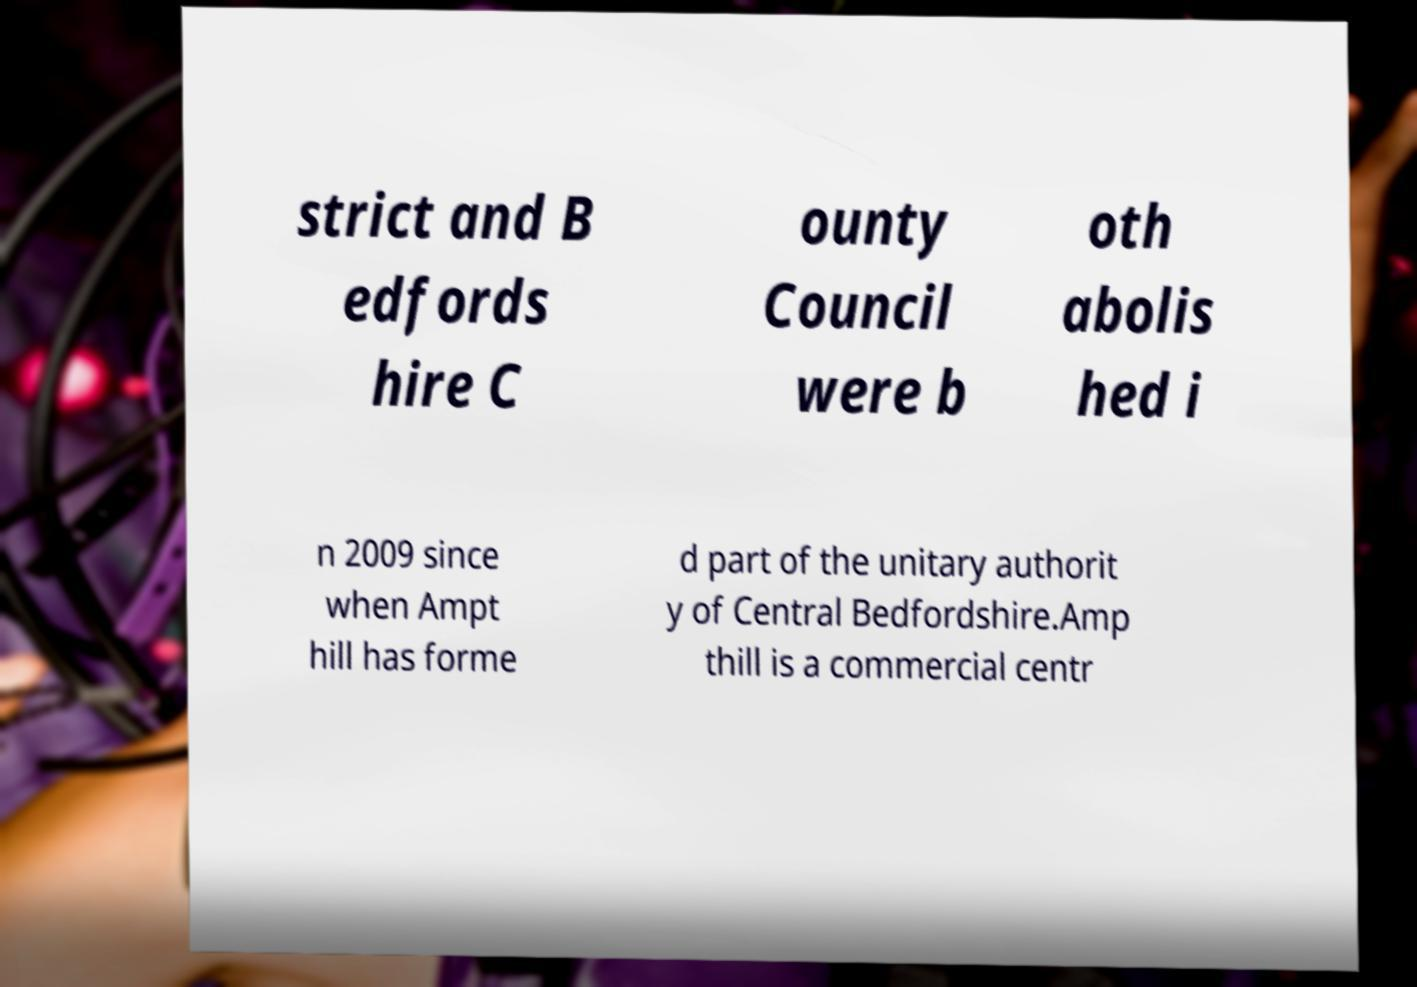Could you assist in decoding the text presented in this image and type it out clearly? strict and B edfords hire C ounty Council were b oth abolis hed i n 2009 since when Ampt hill has forme d part of the unitary authorit y of Central Bedfordshire.Amp thill is a commercial centr 